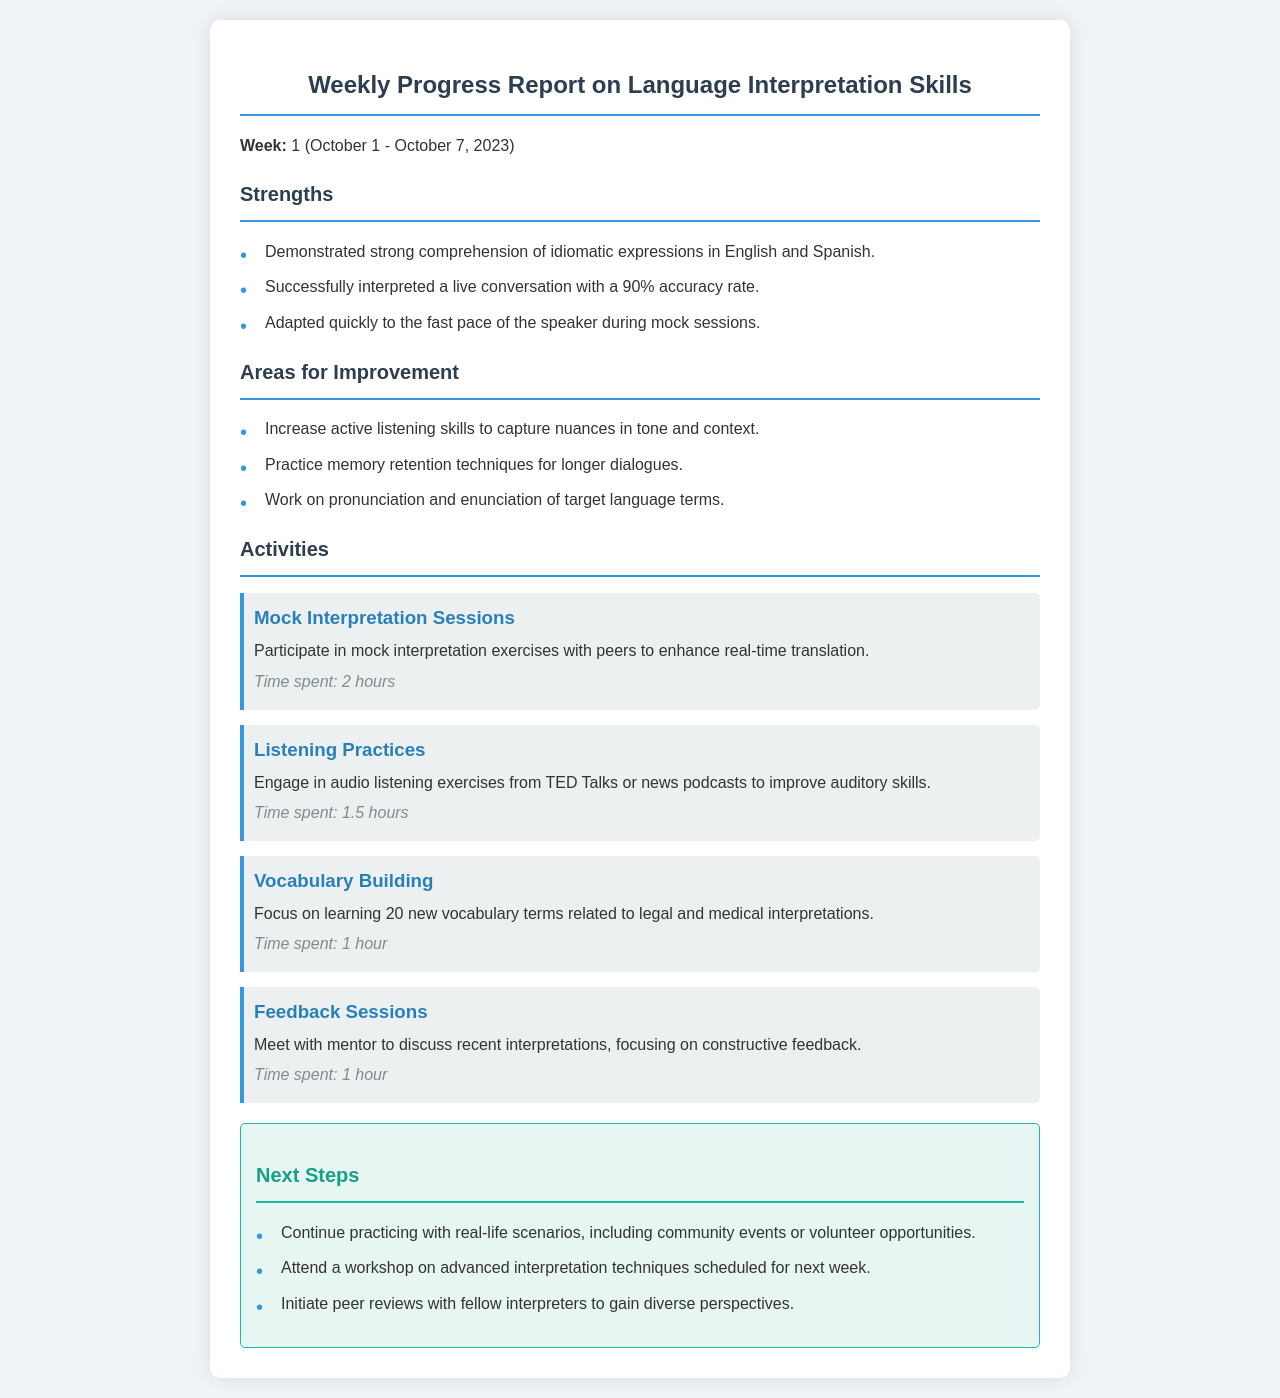what week does the report cover? The report specifies the week from October 1 to October 7, 2023.
Answer: Week 1 (October 1 - October 7, 2023) how many hours were spent on mock interpretation sessions? The time spent on mock interpretation sessions is listed in the activities section.
Answer: 2 hours what is one strength mentioned in the report? The report lists three strengths, one of which is demonstrated strong comprehension of idiomatic expressions.
Answer: Demonstrated strong comprehension of idiomatic expressions in English and Spanish what is one area for improvement identified? The report highlights three areas for improvement, one of which is to increase active listening skills.
Answer: Increase active listening skills to capture nuances in tone and context how many new vocabulary terms are focused on in vocabulary building? The report states the specific number of vocabulary terms to be learned.
Answer: 20 new vocabulary terms what activity helps improve auditory skills? The document specifies an activity geared towards auditory skill improvement.
Answer: Listening Practices how long was the feedback session with the mentor? The time spent for feedback sessions is directly provided in the activity section.
Answer: 1 hour what is one of the next steps listed in the report? The next steps section outlines three actions, one of which is to continue practicing with real-life scenarios.
Answer: Continue practicing with real-life scenarios, including community events or volunteer opportunities 